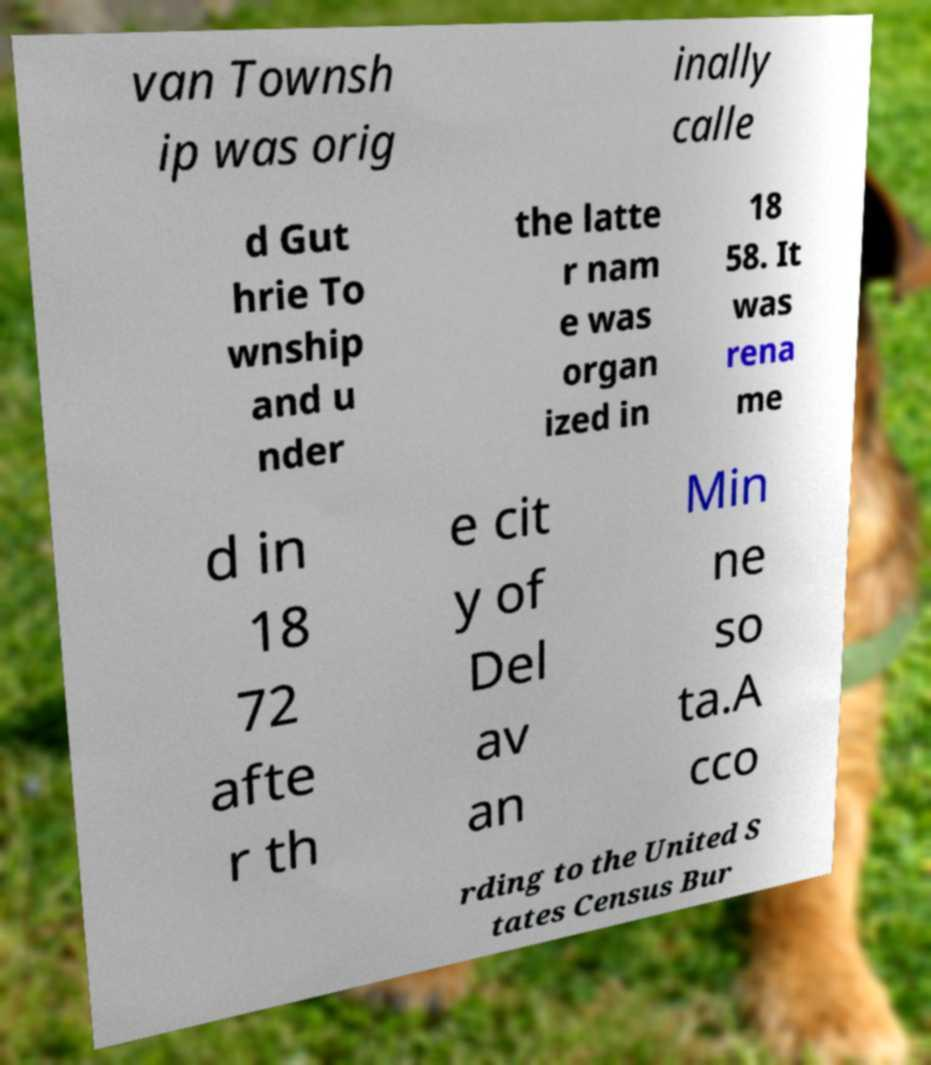Could you assist in decoding the text presented in this image and type it out clearly? van Townsh ip was orig inally calle d Gut hrie To wnship and u nder the latte r nam e was organ ized in 18 58. It was rena me d in 18 72 afte r th e cit y of Del av an Min ne so ta.A cco rding to the United S tates Census Bur 